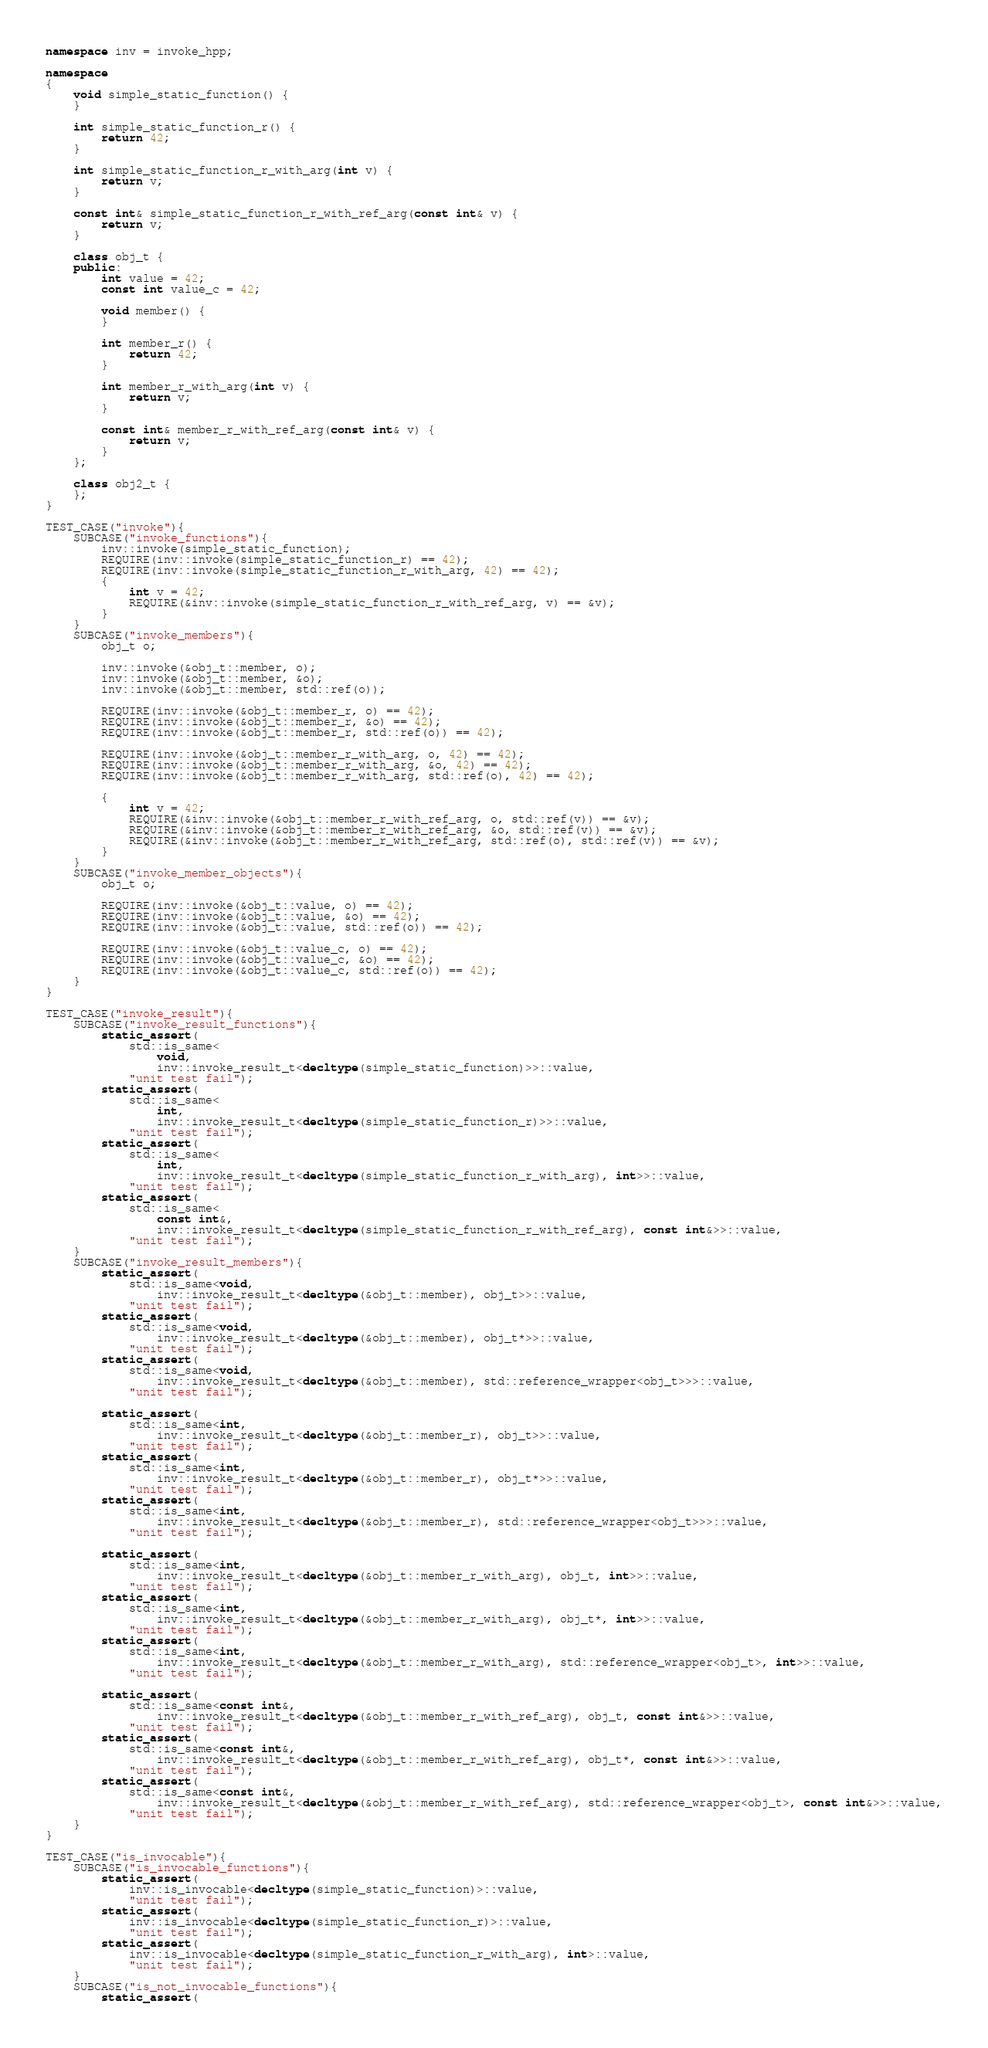Convert code to text. <code><loc_0><loc_0><loc_500><loc_500><_C++_>
namespace inv = invoke_hpp;

namespace
{
    void simple_static_function() {
    }

    int simple_static_function_r() {
        return 42;
    }

    int simple_static_function_r_with_arg(int v) {
        return v;
    }

    const int& simple_static_function_r_with_ref_arg(const int& v) {
        return v;
    }

    class obj_t {
    public:
        int value = 42;
        const int value_c = 42;

        void member() {
        }

        int member_r() {
            return 42;
        }

        int member_r_with_arg(int v) {
            return v;
        }

        const int& member_r_with_ref_arg(const int& v) {
            return v;
        }
    };

    class obj2_t {
    };
}

TEST_CASE("invoke"){
    SUBCASE("invoke_functions"){
        inv::invoke(simple_static_function);
        REQUIRE(inv::invoke(simple_static_function_r) == 42);
        REQUIRE(inv::invoke(simple_static_function_r_with_arg, 42) == 42);
        {
            int v = 42;
            REQUIRE(&inv::invoke(simple_static_function_r_with_ref_arg, v) == &v);
        }
    }
    SUBCASE("invoke_members"){
        obj_t o;

        inv::invoke(&obj_t::member, o);
        inv::invoke(&obj_t::member, &o);
        inv::invoke(&obj_t::member, std::ref(o));

        REQUIRE(inv::invoke(&obj_t::member_r, o) == 42);
        REQUIRE(inv::invoke(&obj_t::member_r, &o) == 42);
        REQUIRE(inv::invoke(&obj_t::member_r, std::ref(o)) == 42);

        REQUIRE(inv::invoke(&obj_t::member_r_with_arg, o, 42) == 42);
        REQUIRE(inv::invoke(&obj_t::member_r_with_arg, &o, 42) == 42);
        REQUIRE(inv::invoke(&obj_t::member_r_with_arg, std::ref(o), 42) == 42);

        {
            int v = 42;
            REQUIRE(&inv::invoke(&obj_t::member_r_with_ref_arg, o, std::ref(v)) == &v);
            REQUIRE(&inv::invoke(&obj_t::member_r_with_ref_arg, &o, std::ref(v)) == &v);
            REQUIRE(&inv::invoke(&obj_t::member_r_with_ref_arg, std::ref(o), std::ref(v)) == &v);
        }
    }
    SUBCASE("invoke_member_objects"){
        obj_t o;

        REQUIRE(inv::invoke(&obj_t::value, o) == 42);
        REQUIRE(inv::invoke(&obj_t::value, &o) == 42);
        REQUIRE(inv::invoke(&obj_t::value, std::ref(o)) == 42);

        REQUIRE(inv::invoke(&obj_t::value_c, o) == 42);
        REQUIRE(inv::invoke(&obj_t::value_c, &o) == 42);
        REQUIRE(inv::invoke(&obj_t::value_c, std::ref(o)) == 42);
    }
}

TEST_CASE("invoke_result"){
    SUBCASE("invoke_result_functions"){
        static_assert(
            std::is_same<
                void,
                inv::invoke_result_t<decltype(simple_static_function)>>::value,
            "unit test fail");
        static_assert(
            std::is_same<
                int,
                inv::invoke_result_t<decltype(simple_static_function_r)>>::value,
            "unit test fail");
        static_assert(
            std::is_same<
                int,
                inv::invoke_result_t<decltype(simple_static_function_r_with_arg), int>>::value,
            "unit test fail");
        static_assert(
            std::is_same<
                const int&,
                inv::invoke_result_t<decltype(simple_static_function_r_with_ref_arg), const int&>>::value,
            "unit test fail");
    }
    SUBCASE("invoke_result_members"){
        static_assert(
            std::is_same<void,
                inv::invoke_result_t<decltype(&obj_t::member), obj_t>>::value,
            "unit test fail");
        static_assert(
            std::is_same<void,
                inv::invoke_result_t<decltype(&obj_t::member), obj_t*>>::value,
            "unit test fail");
        static_assert(
            std::is_same<void,
                inv::invoke_result_t<decltype(&obj_t::member), std::reference_wrapper<obj_t>>>::value,
            "unit test fail");

        static_assert(
            std::is_same<int,
                inv::invoke_result_t<decltype(&obj_t::member_r), obj_t>>::value,
            "unit test fail");
        static_assert(
            std::is_same<int,
                inv::invoke_result_t<decltype(&obj_t::member_r), obj_t*>>::value,
            "unit test fail");
        static_assert(
            std::is_same<int,
                inv::invoke_result_t<decltype(&obj_t::member_r), std::reference_wrapper<obj_t>>>::value,
            "unit test fail");

        static_assert(
            std::is_same<int,
                inv::invoke_result_t<decltype(&obj_t::member_r_with_arg), obj_t, int>>::value,
            "unit test fail");
        static_assert(
            std::is_same<int,
                inv::invoke_result_t<decltype(&obj_t::member_r_with_arg), obj_t*, int>>::value,
            "unit test fail");
        static_assert(
            std::is_same<int,
                inv::invoke_result_t<decltype(&obj_t::member_r_with_arg), std::reference_wrapper<obj_t>, int>>::value,
            "unit test fail");

        static_assert(
            std::is_same<const int&,
                inv::invoke_result_t<decltype(&obj_t::member_r_with_ref_arg), obj_t, const int&>>::value,
            "unit test fail");
        static_assert(
            std::is_same<const int&,
                inv::invoke_result_t<decltype(&obj_t::member_r_with_ref_arg), obj_t*, const int&>>::value,
            "unit test fail");
        static_assert(
            std::is_same<const int&,
                inv::invoke_result_t<decltype(&obj_t::member_r_with_ref_arg), std::reference_wrapper<obj_t>, const int&>>::value,
            "unit test fail");
    }
}

TEST_CASE("is_invocable"){
    SUBCASE("is_invocable_functions"){
        static_assert(
            inv::is_invocable<decltype(simple_static_function)>::value,
            "unit test fail");
        static_assert(
            inv::is_invocable<decltype(simple_static_function_r)>::value,
            "unit test fail");
        static_assert(
            inv::is_invocable<decltype(simple_static_function_r_with_arg), int>::value,
            "unit test fail");
    }
    SUBCASE("is_not_invocable_functions"){
        static_assert(</code> 